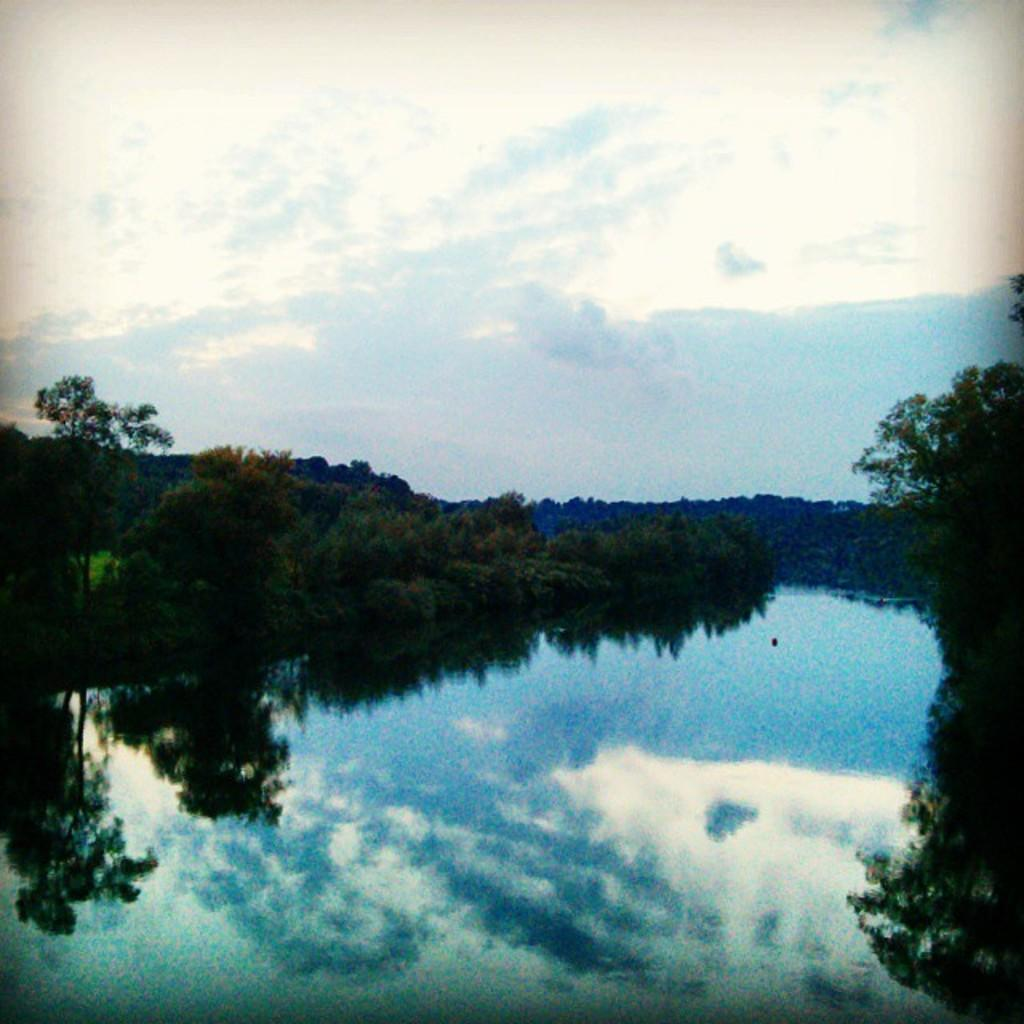What is the main feature of the image? The main feature of the image is a water surface. What can be seen around the water surface? There are trees surrounding the water surface. What is visible in the background of the image? The sky is visible in the background of the image. What can be observed in the sky? Clouds are present in the sky. How many women are sitting in the cellar in the image? There are no women or cellars present in the image. 